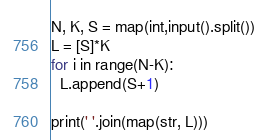<code> <loc_0><loc_0><loc_500><loc_500><_Python_>N, K, S = map(int,input().split())
L = [S]*K
for i in range(N-K):
  L.append(S+1)
  
print(' '.join(map(str, L)))</code> 